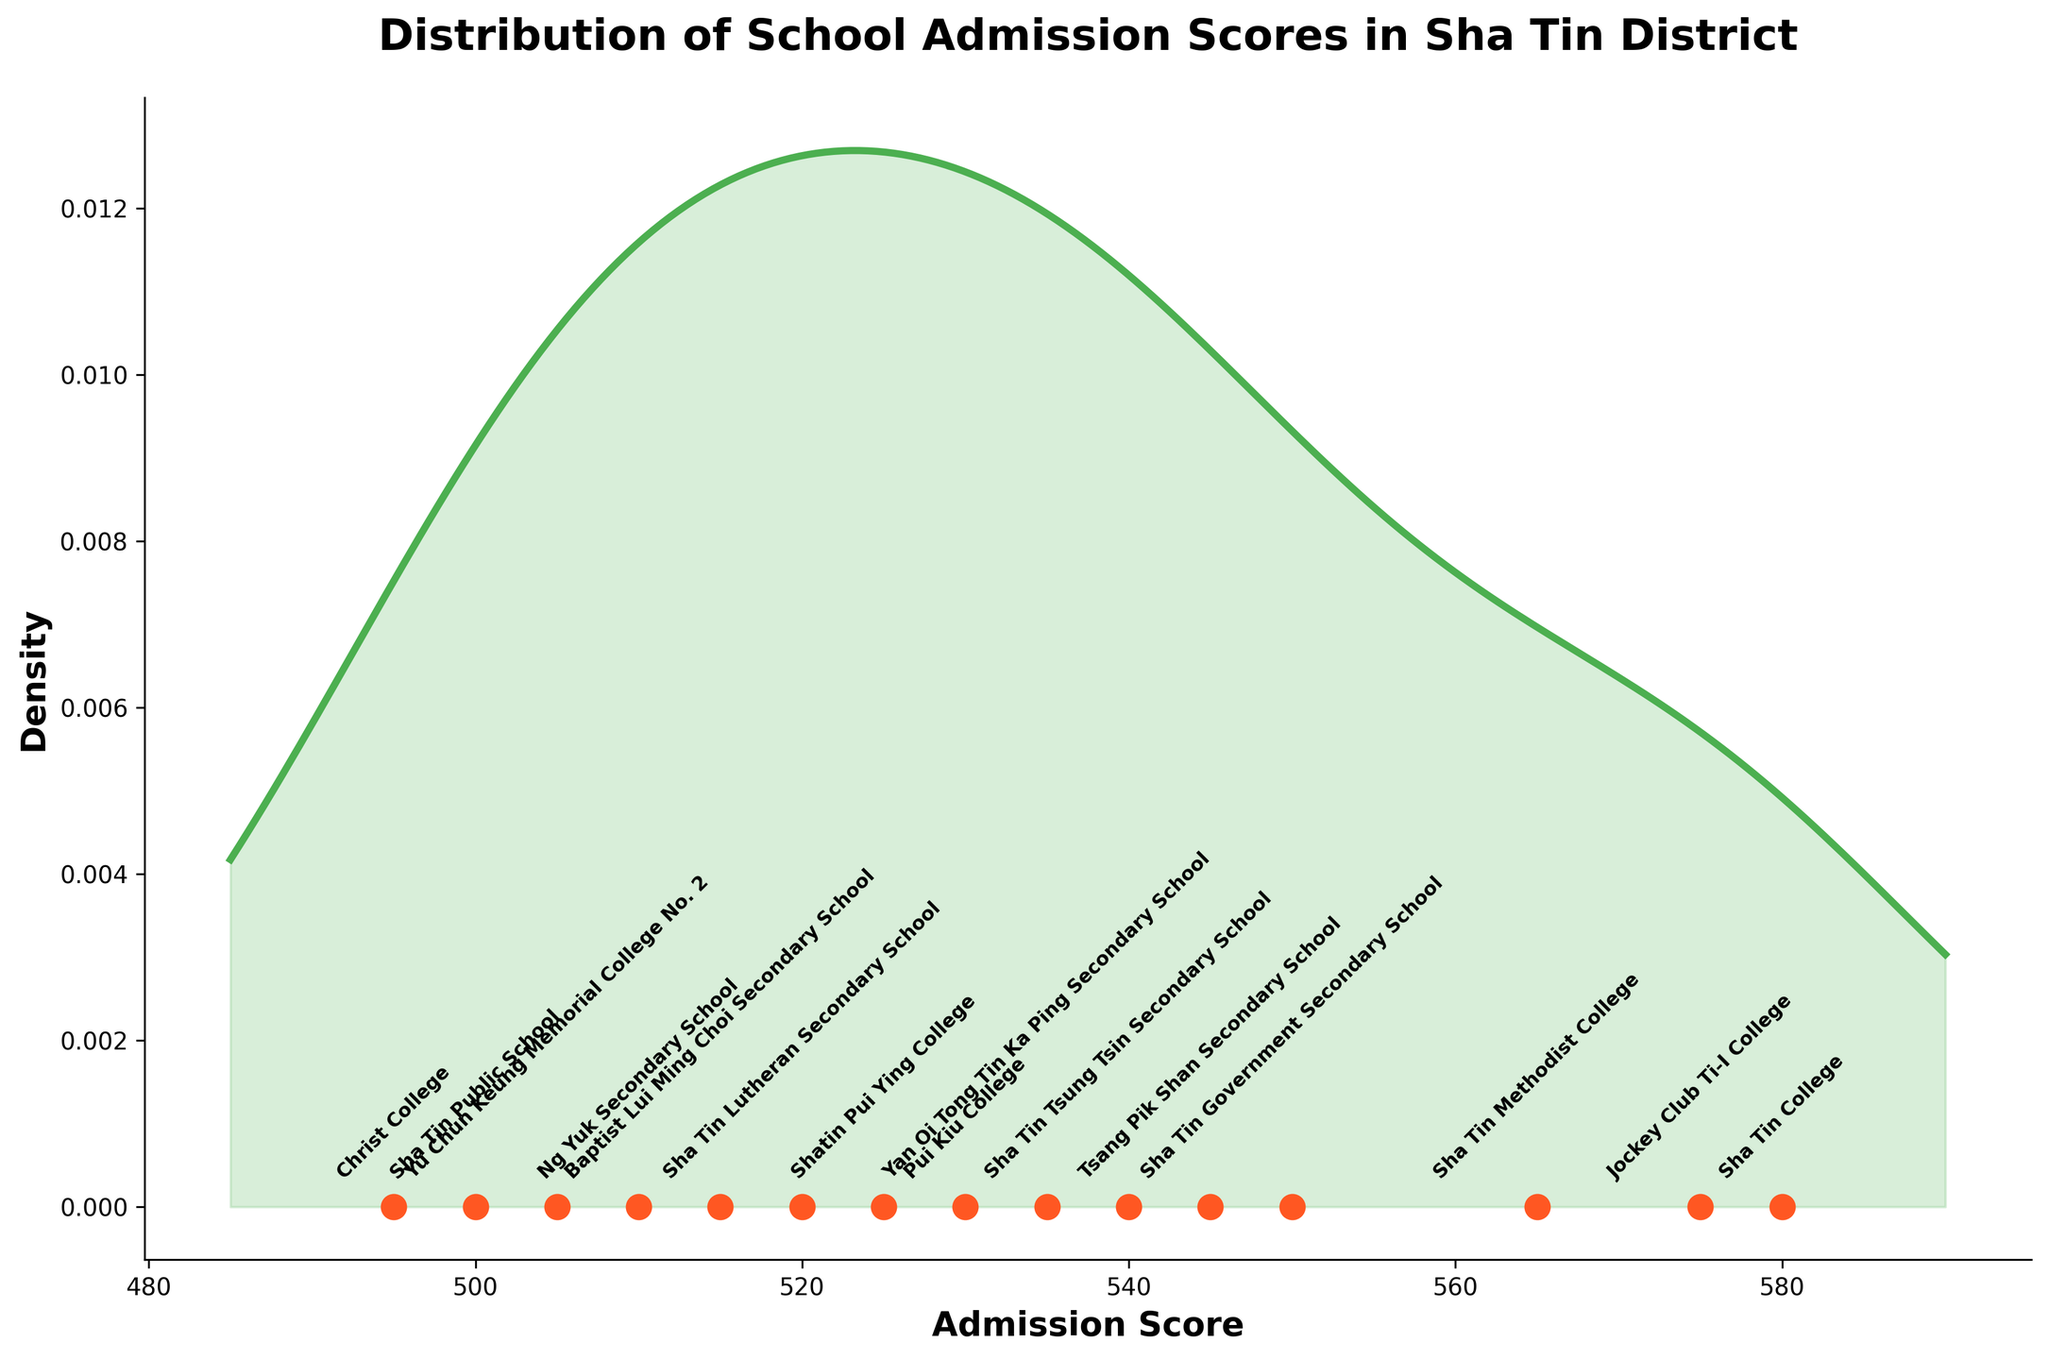What is the title of the plot? The title of the plot is typically displayed prominently at the top. In this figure, it is titled "Distribution of School Admission Scores in Sha Tin District."
Answer: Distribution of School Admission Scores in Sha Tin District How many schools are plotted in the figure? By counting the number of annotated points along the x-axis representing school admission scores, we see there are 15 schools plotted in the figure.
Answer: 15 Which school has the highest admission score? The figure shows the distribution of scores, with each school annotated by name at its respective score. Sha Tin College has the highest score of 580.
Answer: Sha Tin College What is the admission score of Tsang Pik Shan Secondary School? By looking at the position of each school labeled on the x-axis, Tsang Pik Shan Secondary School is positioned at a score of 545.
Answer: 545 How does the admission score of Sha Tin Methodist College compare to that of Sha Tin Government Secondary School? Sha Tin Methodist College has an admission score of 565, while Sha Tin Government Secondary School has a score of 550. Thus, Sha Tin Methodist College has a higher admission score by 15 points.
Answer: Higher by 15 points What is the range of admission scores for these schools? The range is found by subtracting the lowest score from the highest score. The highest score is 580 (Sha Tin College) and the lowest score is 495 (Christ College), giving a range of 85 points.
Answer: 85 points How densely packed are the scores between 500 and 550? By examining the density plot, you can see how the density line behaves between these scores. The density is relatively high in this range, meaning many schools have scores between 500 and 550.
Answer: Relatively high density Which school has an admission score closest to the median of these scores? To find the median, arrange the 15 scores in ascending order and locate the middle value. The 8th score is the median, which is 530 (Pui Kiu College).
Answer: Pui Kiu College Are there more schools with scores above or below 540? Counting schools from the plotted points, there are 6 schools above and 9 schools below the score of 540. Thus, more schools have scores below 540.
Answer: Below 540 